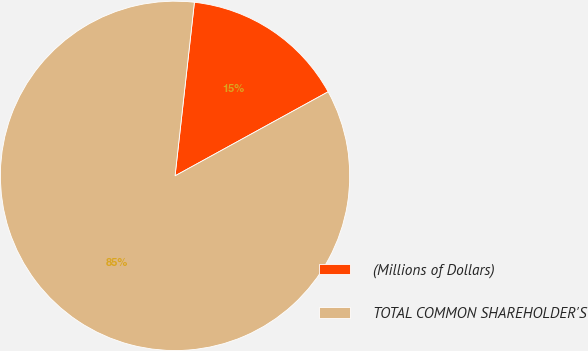Convert chart. <chart><loc_0><loc_0><loc_500><loc_500><pie_chart><fcel>(Millions of Dollars)<fcel>TOTAL COMMON SHAREHOLDER'S<nl><fcel>15.24%<fcel>84.76%<nl></chart> 